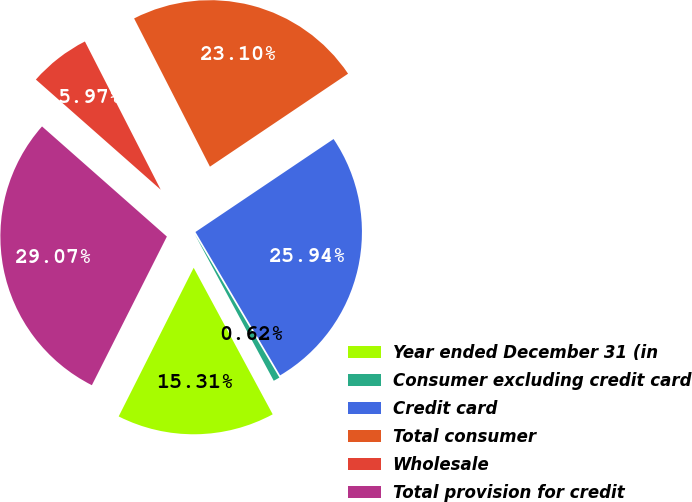Convert chart. <chart><loc_0><loc_0><loc_500><loc_500><pie_chart><fcel>Year ended December 31 (in<fcel>Consumer excluding credit card<fcel>Credit card<fcel>Total consumer<fcel>Wholesale<fcel>Total provision for credit<nl><fcel>15.31%<fcel>0.62%<fcel>25.94%<fcel>23.1%<fcel>5.97%<fcel>29.07%<nl></chart> 